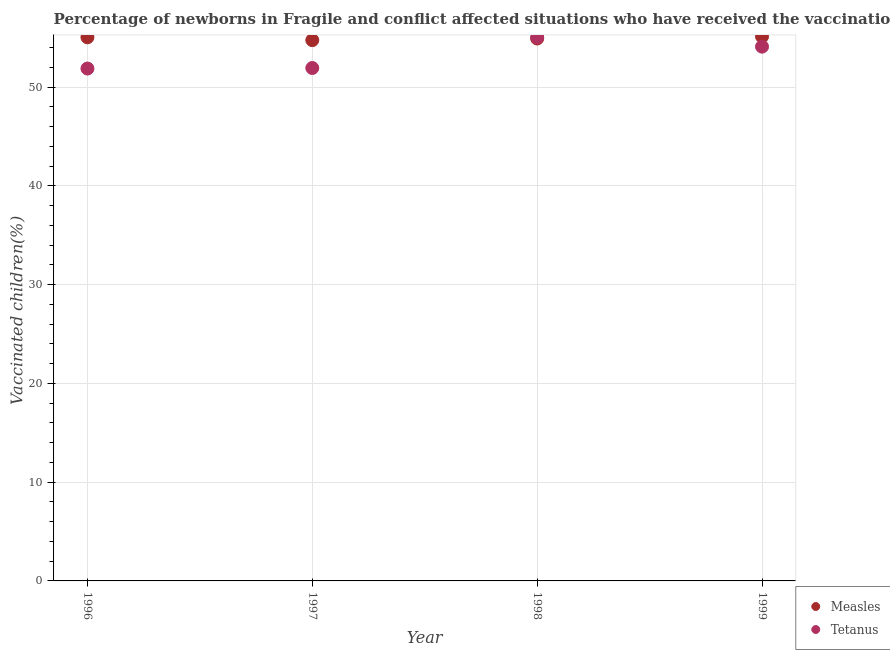Is the number of dotlines equal to the number of legend labels?
Offer a very short reply. Yes. What is the percentage of newborns who received vaccination for measles in 1997?
Offer a very short reply. 54.75. Across all years, what is the maximum percentage of newborns who received vaccination for measles?
Your answer should be compact. 55.12. Across all years, what is the minimum percentage of newborns who received vaccination for tetanus?
Provide a succinct answer. 51.87. In which year was the percentage of newborns who received vaccination for tetanus maximum?
Make the answer very short. 1998. What is the total percentage of newborns who received vaccination for measles in the graph?
Keep it short and to the point. 219.81. What is the difference between the percentage of newborns who received vaccination for measles in 1997 and that in 1998?
Make the answer very short. -0.17. What is the difference between the percentage of newborns who received vaccination for measles in 1999 and the percentage of newborns who received vaccination for tetanus in 1996?
Offer a very short reply. 3.25. What is the average percentage of newborns who received vaccination for measles per year?
Provide a succinct answer. 54.95. In the year 1998, what is the difference between the percentage of newborns who received vaccination for measles and percentage of newborns who received vaccination for tetanus?
Ensure brevity in your answer.  -0.12. What is the ratio of the percentage of newborns who received vaccination for measles in 1996 to that in 1997?
Provide a succinct answer. 1.01. Is the percentage of newborns who received vaccination for tetanus in 1997 less than that in 1998?
Provide a succinct answer. Yes. Is the difference between the percentage of newborns who received vaccination for measles in 1997 and 1998 greater than the difference between the percentage of newborns who received vaccination for tetanus in 1997 and 1998?
Ensure brevity in your answer.  Yes. What is the difference between the highest and the second highest percentage of newborns who received vaccination for measles?
Offer a terse response. 0.08. What is the difference between the highest and the lowest percentage of newborns who received vaccination for tetanus?
Your answer should be very brief. 3.17. In how many years, is the percentage of newborns who received vaccination for measles greater than the average percentage of newborns who received vaccination for measles taken over all years?
Your answer should be compact. 2. Is the sum of the percentage of newborns who received vaccination for tetanus in 1997 and 1999 greater than the maximum percentage of newborns who received vaccination for measles across all years?
Keep it short and to the point. Yes. Does the percentage of newborns who received vaccination for measles monotonically increase over the years?
Ensure brevity in your answer.  No. Is the percentage of newborns who received vaccination for measles strictly greater than the percentage of newborns who received vaccination for tetanus over the years?
Your response must be concise. No. Is the percentage of newborns who received vaccination for measles strictly less than the percentage of newborns who received vaccination for tetanus over the years?
Make the answer very short. No. Where does the legend appear in the graph?
Give a very brief answer. Bottom right. How are the legend labels stacked?
Your answer should be very brief. Vertical. What is the title of the graph?
Your response must be concise. Percentage of newborns in Fragile and conflict affected situations who have received the vaccination. What is the label or title of the Y-axis?
Your answer should be compact. Vaccinated children(%)
. What is the Vaccinated children(%)
 in Measles in 1996?
Provide a short and direct response. 55.03. What is the Vaccinated children(%)
 of Tetanus in 1996?
Keep it short and to the point. 51.87. What is the Vaccinated children(%)
 in Measles in 1997?
Your answer should be very brief. 54.75. What is the Vaccinated children(%)
 in Tetanus in 1997?
Provide a succinct answer. 51.93. What is the Vaccinated children(%)
 of Measles in 1998?
Provide a succinct answer. 54.91. What is the Vaccinated children(%)
 of Tetanus in 1998?
Ensure brevity in your answer.  55.04. What is the Vaccinated children(%)
 in Measles in 1999?
Provide a succinct answer. 55.12. What is the Vaccinated children(%)
 in Tetanus in 1999?
Make the answer very short. 54.09. Across all years, what is the maximum Vaccinated children(%)
 of Measles?
Keep it short and to the point. 55.12. Across all years, what is the maximum Vaccinated children(%)
 in Tetanus?
Offer a very short reply. 55.04. Across all years, what is the minimum Vaccinated children(%)
 in Measles?
Your answer should be very brief. 54.75. Across all years, what is the minimum Vaccinated children(%)
 of Tetanus?
Your answer should be very brief. 51.87. What is the total Vaccinated children(%)
 in Measles in the graph?
Keep it short and to the point. 219.81. What is the total Vaccinated children(%)
 in Tetanus in the graph?
Make the answer very short. 212.92. What is the difference between the Vaccinated children(%)
 in Measles in 1996 and that in 1997?
Provide a short and direct response. 0.29. What is the difference between the Vaccinated children(%)
 in Tetanus in 1996 and that in 1997?
Keep it short and to the point. -0.06. What is the difference between the Vaccinated children(%)
 in Measles in 1996 and that in 1998?
Keep it short and to the point. 0.12. What is the difference between the Vaccinated children(%)
 of Tetanus in 1996 and that in 1998?
Ensure brevity in your answer.  -3.17. What is the difference between the Vaccinated children(%)
 in Measles in 1996 and that in 1999?
Your answer should be very brief. -0.08. What is the difference between the Vaccinated children(%)
 in Tetanus in 1996 and that in 1999?
Your answer should be compact. -2.22. What is the difference between the Vaccinated children(%)
 of Measles in 1997 and that in 1998?
Provide a short and direct response. -0.17. What is the difference between the Vaccinated children(%)
 of Tetanus in 1997 and that in 1998?
Offer a very short reply. -3.11. What is the difference between the Vaccinated children(%)
 of Measles in 1997 and that in 1999?
Your answer should be compact. -0.37. What is the difference between the Vaccinated children(%)
 of Tetanus in 1997 and that in 1999?
Your answer should be very brief. -2.16. What is the difference between the Vaccinated children(%)
 of Measles in 1998 and that in 1999?
Your answer should be very brief. -0.2. What is the difference between the Vaccinated children(%)
 of Tetanus in 1998 and that in 1999?
Offer a very short reply. 0.95. What is the difference between the Vaccinated children(%)
 of Measles in 1996 and the Vaccinated children(%)
 of Tetanus in 1997?
Ensure brevity in your answer.  3.11. What is the difference between the Vaccinated children(%)
 in Measles in 1996 and the Vaccinated children(%)
 in Tetanus in 1998?
Offer a very short reply. -0. What is the difference between the Vaccinated children(%)
 in Measles in 1996 and the Vaccinated children(%)
 in Tetanus in 1999?
Ensure brevity in your answer.  0.95. What is the difference between the Vaccinated children(%)
 in Measles in 1997 and the Vaccinated children(%)
 in Tetanus in 1998?
Provide a succinct answer. -0.29. What is the difference between the Vaccinated children(%)
 of Measles in 1997 and the Vaccinated children(%)
 of Tetanus in 1999?
Offer a very short reply. 0.66. What is the difference between the Vaccinated children(%)
 in Measles in 1998 and the Vaccinated children(%)
 in Tetanus in 1999?
Provide a succinct answer. 0.82. What is the average Vaccinated children(%)
 in Measles per year?
Offer a terse response. 54.95. What is the average Vaccinated children(%)
 of Tetanus per year?
Offer a very short reply. 53.23. In the year 1996, what is the difference between the Vaccinated children(%)
 of Measles and Vaccinated children(%)
 of Tetanus?
Make the answer very short. 3.16. In the year 1997, what is the difference between the Vaccinated children(%)
 in Measles and Vaccinated children(%)
 in Tetanus?
Provide a succinct answer. 2.82. In the year 1998, what is the difference between the Vaccinated children(%)
 of Measles and Vaccinated children(%)
 of Tetanus?
Keep it short and to the point. -0.12. In the year 1999, what is the difference between the Vaccinated children(%)
 of Measles and Vaccinated children(%)
 of Tetanus?
Provide a succinct answer. 1.03. What is the ratio of the Vaccinated children(%)
 in Measles in 1996 to that in 1997?
Offer a very short reply. 1.01. What is the ratio of the Vaccinated children(%)
 in Measles in 1996 to that in 1998?
Offer a very short reply. 1. What is the ratio of the Vaccinated children(%)
 in Tetanus in 1996 to that in 1998?
Your answer should be very brief. 0.94. What is the ratio of the Vaccinated children(%)
 of Measles in 1997 to that in 1998?
Provide a succinct answer. 1. What is the ratio of the Vaccinated children(%)
 of Tetanus in 1997 to that in 1998?
Provide a short and direct response. 0.94. What is the ratio of the Vaccinated children(%)
 of Measles in 1997 to that in 1999?
Your response must be concise. 0.99. What is the ratio of the Vaccinated children(%)
 in Tetanus in 1998 to that in 1999?
Offer a terse response. 1.02. What is the difference between the highest and the second highest Vaccinated children(%)
 in Measles?
Give a very brief answer. 0.08. What is the difference between the highest and the second highest Vaccinated children(%)
 in Tetanus?
Your answer should be compact. 0.95. What is the difference between the highest and the lowest Vaccinated children(%)
 of Measles?
Give a very brief answer. 0.37. What is the difference between the highest and the lowest Vaccinated children(%)
 of Tetanus?
Provide a succinct answer. 3.17. 